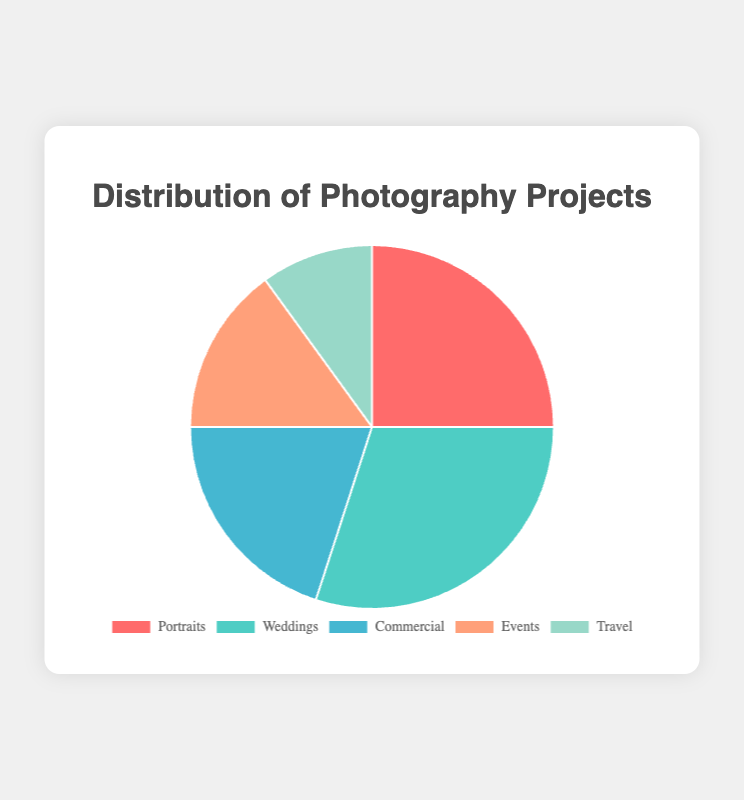What percentage of the projects are either Portraits or Weddings? Combine the percentages for Portraits and Weddings. Portraits account for 25% and Weddings for 30%. So, their combined contribution is 25% + 30% = 55%.
Answer: 55% Which type of photography project is the least common? By comparing the percentages of each type of photography project, Travel has the smallest percentage, which is 10%.
Answer: Travel How much more common are Wedding projects compared to Travel projects? Calculate the difference in percentage between Weddings and Travel. Weddings are 30%, and Travel is 10%. The difference is 30% - 10% = 20%.
Answer: 20% Are Commercial and Events projects together more common than Weddings alone? Combine the percentages of Commercial and Events. Commercial is 20%, and Events are 15%, making a total of 20% + 15% = 35%. Weddings alone are 30%. Thus, 35% (Commercial + Events) > 30% (Weddings alone).
Answer: Yes What proportion of the photography projects does not consist of Portraits and Weddings? First, sum the percentages of Portraits and Weddings, which are 25% + 30% = 55%. Then, subtract this number from 100% to get the proportion of projects that are not Portraits and Weddings: 100% - 55% = 45%.
Answer: 45% Which project type has a visual section colored blue? Identify the project type associated with the blue color in the chart. According to the provided color information, 'Commercial' is represented by blue.
Answer: Commercial Is the percentage of Events and Travel projects together less than the percentage of Weddings? Add up the percentages of Events and Travel. Events make up 15% and Travel 10%, giving a total of 15% + 10% = 25%. Compare this to Weddings at 30%. Since 25% < 30%, Events and Travel are less common than Weddings.
Answer: Yes What percentage of photography projects falls into the major three categories (Portraits, Weddings, and Commercial)? Add the percentages of Portraits, Weddings, and Commercial. Portraits are 25%, Weddings 30%, and Commercial 20%. Their combined total is 25% + 30% + 20% = 75%.
Answer: 75% Which category follows Weddings in percentage size, and what is its color? Determine the second highest percentage after Weddings at 30%, which is Portraits at 25%. The color associated with Portraits is red.
Answer: Portraits, red 